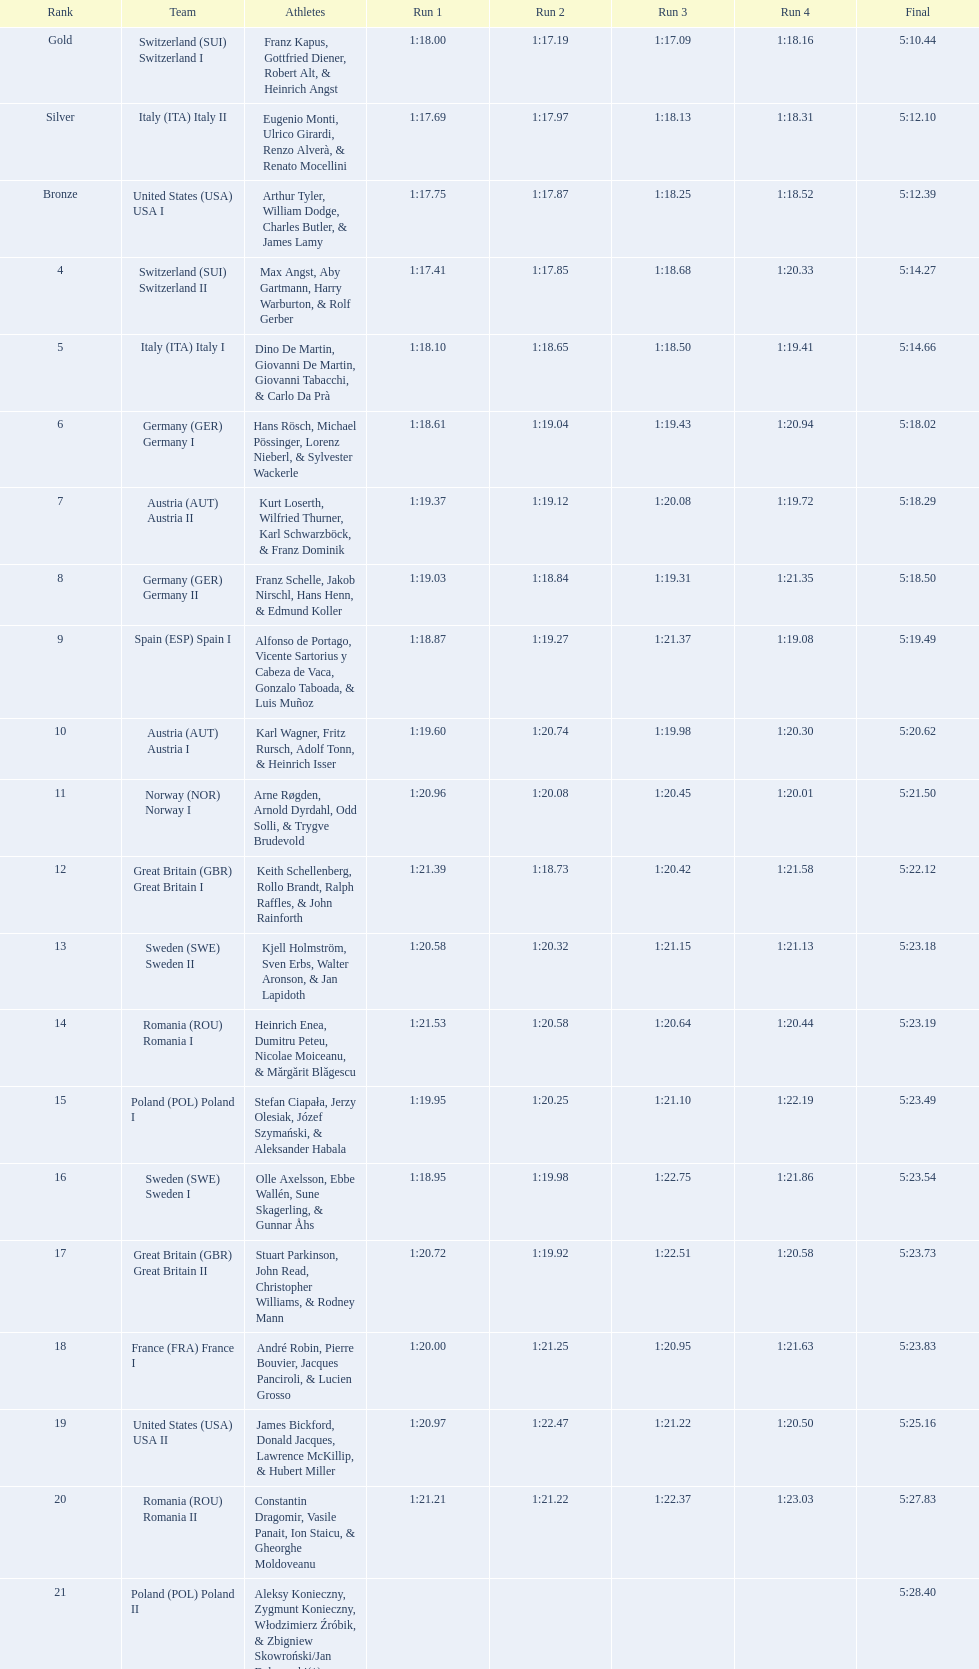Which team had the most time? Poland. 